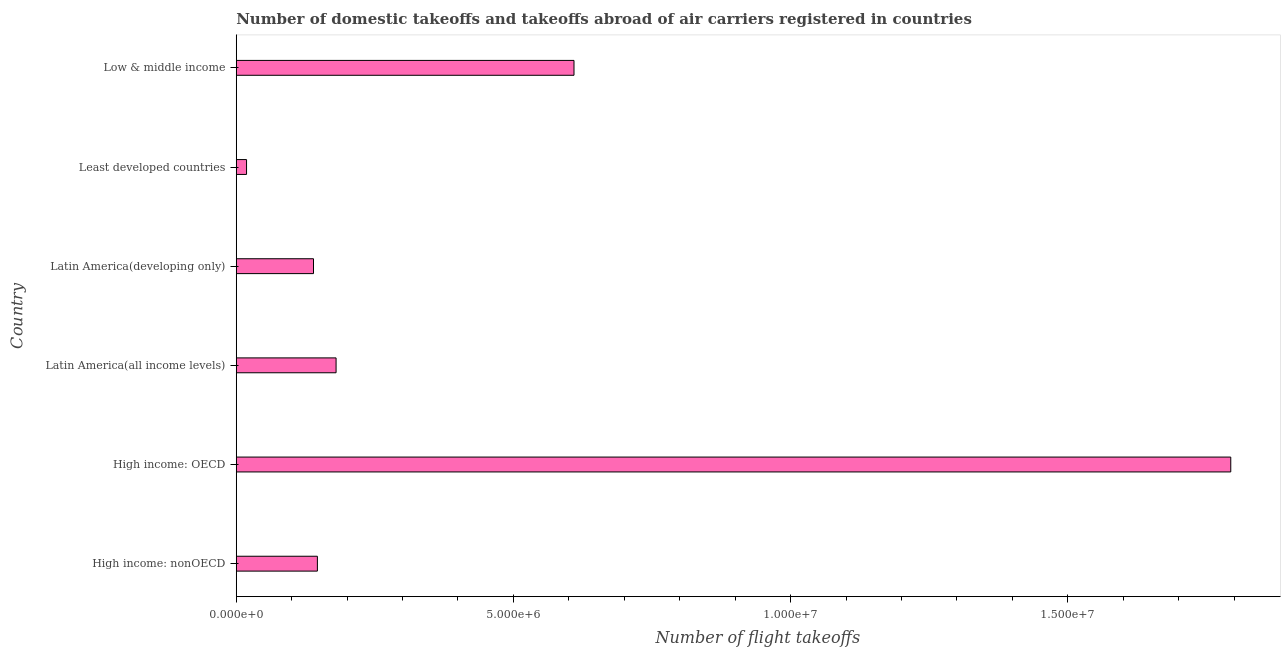Does the graph contain any zero values?
Ensure brevity in your answer.  No. Does the graph contain grids?
Your answer should be very brief. No. What is the title of the graph?
Your response must be concise. Number of domestic takeoffs and takeoffs abroad of air carriers registered in countries. What is the label or title of the X-axis?
Offer a very short reply. Number of flight takeoffs. What is the number of flight takeoffs in Latin America(all income levels)?
Provide a short and direct response. 1.80e+06. Across all countries, what is the maximum number of flight takeoffs?
Your answer should be compact. 1.79e+07. Across all countries, what is the minimum number of flight takeoffs?
Make the answer very short. 1.86e+05. In which country was the number of flight takeoffs maximum?
Keep it short and to the point. High income: OECD. In which country was the number of flight takeoffs minimum?
Ensure brevity in your answer.  Least developed countries. What is the sum of the number of flight takeoffs?
Ensure brevity in your answer.  2.89e+07. What is the difference between the number of flight takeoffs in Latin America(all income levels) and Low & middle income?
Keep it short and to the point. -4.29e+06. What is the average number of flight takeoffs per country?
Give a very brief answer. 4.81e+06. What is the median number of flight takeoffs?
Provide a short and direct response. 1.63e+06. What is the ratio of the number of flight takeoffs in Latin America(all income levels) to that in Latin America(developing only)?
Ensure brevity in your answer.  1.29. Is the number of flight takeoffs in Latin America(developing only) less than that in Low & middle income?
Ensure brevity in your answer.  Yes. Is the difference between the number of flight takeoffs in Latin America(developing only) and Least developed countries greater than the difference between any two countries?
Offer a terse response. No. What is the difference between the highest and the second highest number of flight takeoffs?
Provide a short and direct response. 1.18e+07. What is the difference between the highest and the lowest number of flight takeoffs?
Offer a terse response. 1.78e+07. In how many countries, is the number of flight takeoffs greater than the average number of flight takeoffs taken over all countries?
Ensure brevity in your answer.  2. How many bars are there?
Your response must be concise. 6. How many countries are there in the graph?
Your answer should be very brief. 6. What is the difference between two consecutive major ticks on the X-axis?
Offer a very short reply. 5.00e+06. Are the values on the major ticks of X-axis written in scientific E-notation?
Offer a terse response. Yes. What is the Number of flight takeoffs of High income: nonOECD?
Provide a short and direct response. 1.46e+06. What is the Number of flight takeoffs of High income: OECD?
Give a very brief answer. 1.79e+07. What is the Number of flight takeoffs of Latin America(all income levels)?
Your response must be concise. 1.80e+06. What is the Number of flight takeoffs in Latin America(developing only)?
Your answer should be very brief. 1.39e+06. What is the Number of flight takeoffs in Least developed countries?
Offer a very short reply. 1.86e+05. What is the Number of flight takeoffs in Low & middle income?
Ensure brevity in your answer.  6.09e+06. What is the difference between the Number of flight takeoffs in High income: nonOECD and High income: OECD?
Give a very brief answer. -1.65e+07. What is the difference between the Number of flight takeoffs in High income: nonOECD and Latin America(all income levels)?
Make the answer very short. -3.37e+05. What is the difference between the Number of flight takeoffs in High income: nonOECD and Latin America(developing only)?
Provide a succinct answer. 7.01e+04. What is the difference between the Number of flight takeoffs in High income: nonOECD and Least developed countries?
Make the answer very short. 1.28e+06. What is the difference between the Number of flight takeoffs in High income: nonOECD and Low & middle income?
Your response must be concise. -4.63e+06. What is the difference between the Number of flight takeoffs in High income: OECD and Latin America(all income levels)?
Offer a very short reply. 1.61e+07. What is the difference between the Number of flight takeoffs in High income: OECD and Latin America(developing only)?
Your answer should be compact. 1.65e+07. What is the difference between the Number of flight takeoffs in High income: OECD and Least developed countries?
Your answer should be very brief. 1.78e+07. What is the difference between the Number of flight takeoffs in High income: OECD and Low & middle income?
Your answer should be compact. 1.18e+07. What is the difference between the Number of flight takeoffs in Latin America(all income levels) and Latin America(developing only)?
Your response must be concise. 4.07e+05. What is the difference between the Number of flight takeoffs in Latin America(all income levels) and Least developed countries?
Keep it short and to the point. 1.62e+06. What is the difference between the Number of flight takeoffs in Latin America(all income levels) and Low & middle income?
Offer a very short reply. -4.29e+06. What is the difference between the Number of flight takeoffs in Latin America(developing only) and Least developed countries?
Give a very brief answer. 1.21e+06. What is the difference between the Number of flight takeoffs in Latin America(developing only) and Low & middle income?
Give a very brief answer. -4.70e+06. What is the difference between the Number of flight takeoffs in Least developed countries and Low & middle income?
Offer a very short reply. -5.91e+06. What is the ratio of the Number of flight takeoffs in High income: nonOECD to that in High income: OECD?
Ensure brevity in your answer.  0.08. What is the ratio of the Number of flight takeoffs in High income: nonOECD to that in Latin America(all income levels)?
Make the answer very short. 0.81. What is the ratio of the Number of flight takeoffs in High income: nonOECD to that in Latin America(developing only)?
Offer a terse response. 1.05. What is the ratio of the Number of flight takeoffs in High income: nonOECD to that in Least developed countries?
Offer a very short reply. 7.88. What is the ratio of the Number of flight takeoffs in High income: nonOECD to that in Low & middle income?
Offer a very short reply. 0.24. What is the ratio of the Number of flight takeoffs in High income: OECD to that in Latin America(all income levels)?
Your answer should be very brief. 9.96. What is the ratio of the Number of flight takeoffs in High income: OECD to that in Latin America(developing only)?
Provide a short and direct response. 12.87. What is the ratio of the Number of flight takeoffs in High income: OECD to that in Least developed countries?
Your response must be concise. 96.58. What is the ratio of the Number of flight takeoffs in High income: OECD to that in Low & middle income?
Provide a short and direct response. 2.94. What is the ratio of the Number of flight takeoffs in Latin America(all income levels) to that in Latin America(developing only)?
Provide a succinct answer. 1.29. What is the ratio of the Number of flight takeoffs in Latin America(all income levels) to that in Least developed countries?
Ensure brevity in your answer.  9.69. What is the ratio of the Number of flight takeoffs in Latin America(all income levels) to that in Low & middle income?
Your response must be concise. 0.3. What is the ratio of the Number of flight takeoffs in Latin America(developing only) to that in Least developed countries?
Offer a terse response. 7.5. What is the ratio of the Number of flight takeoffs in Latin America(developing only) to that in Low & middle income?
Offer a very short reply. 0.23. 